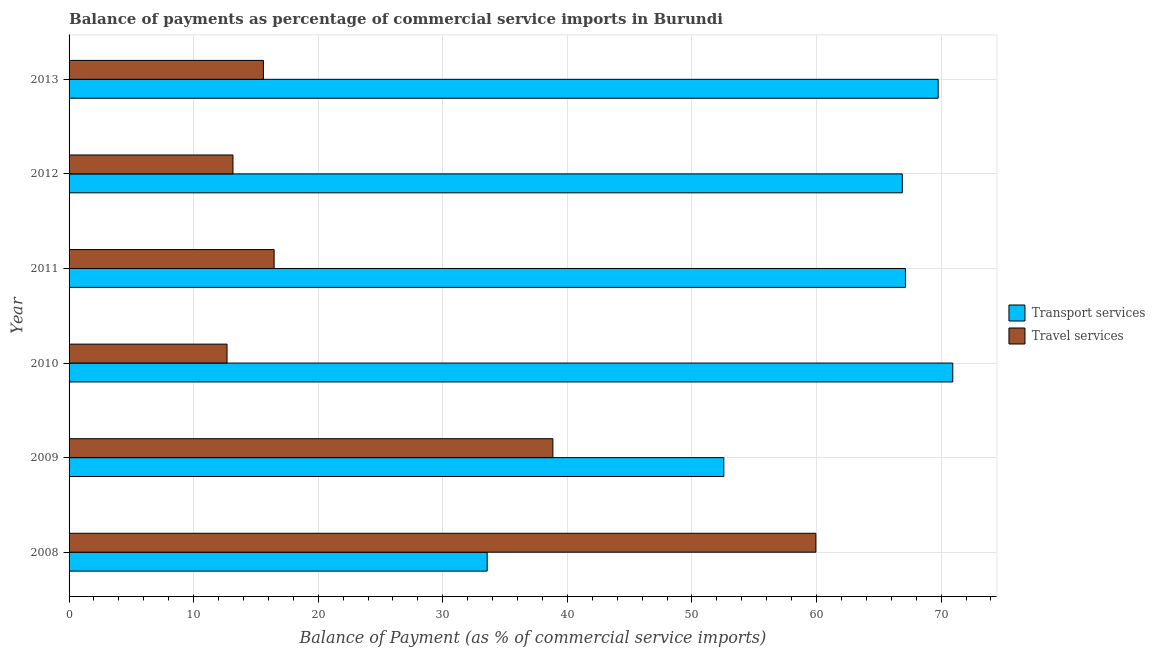How many groups of bars are there?
Give a very brief answer. 6. Are the number of bars on each tick of the Y-axis equal?
Keep it short and to the point. Yes. How many bars are there on the 3rd tick from the top?
Ensure brevity in your answer.  2. What is the label of the 4th group of bars from the top?
Your answer should be very brief. 2010. In how many cases, is the number of bars for a given year not equal to the number of legend labels?
Offer a very short reply. 0. What is the balance of payments of travel services in 2010?
Your answer should be compact. 12.68. Across all years, what is the maximum balance of payments of transport services?
Your response must be concise. 70.93. Across all years, what is the minimum balance of payments of travel services?
Your response must be concise. 12.68. In which year was the balance of payments of travel services maximum?
Ensure brevity in your answer.  2008. In which year was the balance of payments of travel services minimum?
Make the answer very short. 2010. What is the total balance of payments of travel services in the graph?
Ensure brevity in your answer.  156.67. What is the difference between the balance of payments of transport services in 2008 and that in 2011?
Ensure brevity in your answer.  -33.57. What is the difference between the balance of payments of travel services in 2011 and the balance of payments of transport services in 2010?
Provide a succinct answer. -54.47. What is the average balance of payments of transport services per year?
Your answer should be compact. 60.14. In the year 2012, what is the difference between the balance of payments of transport services and balance of payments of travel services?
Keep it short and to the point. 53.72. What is the ratio of the balance of payments of transport services in 2010 to that in 2011?
Your answer should be compact. 1.06. What is the difference between the highest and the second highest balance of payments of transport services?
Offer a terse response. 1.17. What is the difference between the highest and the lowest balance of payments of travel services?
Offer a terse response. 47.27. Is the sum of the balance of payments of travel services in 2009 and 2011 greater than the maximum balance of payments of transport services across all years?
Ensure brevity in your answer.  No. What does the 1st bar from the top in 2013 represents?
Provide a short and direct response. Travel services. What does the 2nd bar from the bottom in 2008 represents?
Give a very brief answer. Travel services. Are the values on the major ticks of X-axis written in scientific E-notation?
Your answer should be compact. No. Where does the legend appear in the graph?
Your response must be concise. Center right. How are the legend labels stacked?
Provide a succinct answer. Vertical. What is the title of the graph?
Offer a terse response. Balance of payments as percentage of commercial service imports in Burundi. What is the label or title of the X-axis?
Provide a succinct answer. Balance of Payment (as % of commercial service imports). What is the label or title of the Y-axis?
Provide a succinct answer. Year. What is the Balance of Payment (as % of commercial service imports) of Transport services in 2008?
Your response must be concise. 33.56. What is the Balance of Payment (as % of commercial service imports) of Travel services in 2008?
Provide a short and direct response. 59.94. What is the Balance of Payment (as % of commercial service imports) of Transport services in 2009?
Your answer should be compact. 52.56. What is the Balance of Payment (as % of commercial service imports) in Travel services in 2009?
Your response must be concise. 38.83. What is the Balance of Payment (as % of commercial service imports) in Transport services in 2010?
Your answer should be compact. 70.93. What is the Balance of Payment (as % of commercial service imports) of Travel services in 2010?
Your answer should be compact. 12.68. What is the Balance of Payment (as % of commercial service imports) of Transport services in 2011?
Provide a succinct answer. 67.13. What is the Balance of Payment (as % of commercial service imports) in Travel services in 2011?
Your response must be concise. 16.46. What is the Balance of Payment (as % of commercial service imports) of Transport services in 2012?
Provide a short and direct response. 66.88. What is the Balance of Payment (as % of commercial service imports) of Travel services in 2012?
Make the answer very short. 13.16. What is the Balance of Payment (as % of commercial service imports) in Transport services in 2013?
Provide a short and direct response. 69.76. What is the Balance of Payment (as % of commercial service imports) in Travel services in 2013?
Ensure brevity in your answer.  15.6. Across all years, what is the maximum Balance of Payment (as % of commercial service imports) of Transport services?
Make the answer very short. 70.93. Across all years, what is the maximum Balance of Payment (as % of commercial service imports) of Travel services?
Offer a terse response. 59.94. Across all years, what is the minimum Balance of Payment (as % of commercial service imports) of Transport services?
Ensure brevity in your answer.  33.56. Across all years, what is the minimum Balance of Payment (as % of commercial service imports) in Travel services?
Ensure brevity in your answer.  12.68. What is the total Balance of Payment (as % of commercial service imports) in Transport services in the graph?
Your answer should be compact. 360.82. What is the total Balance of Payment (as % of commercial service imports) in Travel services in the graph?
Your response must be concise. 156.67. What is the difference between the Balance of Payment (as % of commercial service imports) in Transport services in 2008 and that in 2009?
Make the answer very short. -18.99. What is the difference between the Balance of Payment (as % of commercial service imports) in Travel services in 2008 and that in 2009?
Your answer should be very brief. 21.11. What is the difference between the Balance of Payment (as % of commercial service imports) in Transport services in 2008 and that in 2010?
Offer a very short reply. -37.37. What is the difference between the Balance of Payment (as % of commercial service imports) of Travel services in 2008 and that in 2010?
Make the answer very short. 47.27. What is the difference between the Balance of Payment (as % of commercial service imports) of Transport services in 2008 and that in 2011?
Offer a very short reply. -33.57. What is the difference between the Balance of Payment (as % of commercial service imports) of Travel services in 2008 and that in 2011?
Make the answer very short. 43.49. What is the difference between the Balance of Payment (as % of commercial service imports) of Transport services in 2008 and that in 2012?
Give a very brief answer. -33.32. What is the difference between the Balance of Payment (as % of commercial service imports) of Travel services in 2008 and that in 2012?
Your answer should be very brief. 46.79. What is the difference between the Balance of Payment (as % of commercial service imports) in Transport services in 2008 and that in 2013?
Provide a short and direct response. -36.2. What is the difference between the Balance of Payment (as % of commercial service imports) of Travel services in 2008 and that in 2013?
Your answer should be compact. 44.34. What is the difference between the Balance of Payment (as % of commercial service imports) in Transport services in 2009 and that in 2010?
Keep it short and to the point. -18.38. What is the difference between the Balance of Payment (as % of commercial service imports) in Travel services in 2009 and that in 2010?
Your response must be concise. 26.16. What is the difference between the Balance of Payment (as % of commercial service imports) of Transport services in 2009 and that in 2011?
Ensure brevity in your answer.  -14.58. What is the difference between the Balance of Payment (as % of commercial service imports) in Travel services in 2009 and that in 2011?
Offer a very short reply. 22.37. What is the difference between the Balance of Payment (as % of commercial service imports) in Transport services in 2009 and that in 2012?
Make the answer very short. -14.32. What is the difference between the Balance of Payment (as % of commercial service imports) of Travel services in 2009 and that in 2012?
Keep it short and to the point. 25.68. What is the difference between the Balance of Payment (as % of commercial service imports) in Transport services in 2009 and that in 2013?
Keep it short and to the point. -17.21. What is the difference between the Balance of Payment (as % of commercial service imports) of Travel services in 2009 and that in 2013?
Offer a very short reply. 23.23. What is the difference between the Balance of Payment (as % of commercial service imports) in Transport services in 2010 and that in 2011?
Ensure brevity in your answer.  3.8. What is the difference between the Balance of Payment (as % of commercial service imports) in Travel services in 2010 and that in 2011?
Your answer should be compact. -3.78. What is the difference between the Balance of Payment (as % of commercial service imports) of Transport services in 2010 and that in 2012?
Your answer should be compact. 4.05. What is the difference between the Balance of Payment (as % of commercial service imports) of Travel services in 2010 and that in 2012?
Keep it short and to the point. -0.48. What is the difference between the Balance of Payment (as % of commercial service imports) of Transport services in 2010 and that in 2013?
Ensure brevity in your answer.  1.17. What is the difference between the Balance of Payment (as % of commercial service imports) of Travel services in 2010 and that in 2013?
Give a very brief answer. -2.92. What is the difference between the Balance of Payment (as % of commercial service imports) in Transport services in 2011 and that in 2012?
Offer a very short reply. 0.25. What is the difference between the Balance of Payment (as % of commercial service imports) in Travel services in 2011 and that in 2012?
Your response must be concise. 3.3. What is the difference between the Balance of Payment (as % of commercial service imports) of Transport services in 2011 and that in 2013?
Keep it short and to the point. -2.63. What is the difference between the Balance of Payment (as % of commercial service imports) in Travel services in 2011 and that in 2013?
Your answer should be compact. 0.86. What is the difference between the Balance of Payment (as % of commercial service imports) in Transport services in 2012 and that in 2013?
Ensure brevity in your answer.  -2.88. What is the difference between the Balance of Payment (as % of commercial service imports) in Travel services in 2012 and that in 2013?
Provide a short and direct response. -2.45. What is the difference between the Balance of Payment (as % of commercial service imports) in Transport services in 2008 and the Balance of Payment (as % of commercial service imports) in Travel services in 2009?
Ensure brevity in your answer.  -5.27. What is the difference between the Balance of Payment (as % of commercial service imports) of Transport services in 2008 and the Balance of Payment (as % of commercial service imports) of Travel services in 2010?
Offer a very short reply. 20.88. What is the difference between the Balance of Payment (as % of commercial service imports) of Transport services in 2008 and the Balance of Payment (as % of commercial service imports) of Travel services in 2011?
Ensure brevity in your answer.  17.1. What is the difference between the Balance of Payment (as % of commercial service imports) in Transport services in 2008 and the Balance of Payment (as % of commercial service imports) in Travel services in 2012?
Ensure brevity in your answer.  20.41. What is the difference between the Balance of Payment (as % of commercial service imports) in Transport services in 2008 and the Balance of Payment (as % of commercial service imports) in Travel services in 2013?
Give a very brief answer. 17.96. What is the difference between the Balance of Payment (as % of commercial service imports) in Transport services in 2009 and the Balance of Payment (as % of commercial service imports) in Travel services in 2010?
Offer a terse response. 39.88. What is the difference between the Balance of Payment (as % of commercial service imports) in Transport services in 2009 and the Balance of Payment (as % of commercial service imports) in Travel services in 2011?
Your answer should be very brief. 36.1. What is the difference between the Balance of Payment (as % of commercial service imports) in Transport services in 2009 and the Balance of Payment (as % of commercial service imports) in Travel services in 2012?
Give a very brief answer. 39.4. What is the difference between the Balance of Payment (as % of commercial service imports) of Transport services in 2009 and the Balance of Payment (as % of commercial service imports) of Travel services in 2013?
Provide a succinct answer. 36.95. What is the difference between the Balance of Payment (as % of commercial service imports) in Transport services in 2010 and the Balance of Payment (as % of commercial service imports) in Travel services in 2011?
Provide a succinct answer. 54.47. What is the difference between the Balance of Payment (as % of commercial service imports) of Transport services in 2010 and the Balance of Payment (as % of commercial service imports) of Travel services in 2012?
Keep it short and to the point. 57.78. What is the difference between the Balance of Payment (as % of commercial service imports) of Transport services in 2010 and the Balance of Payment (as % of commercial service imports) of Travel services in 2013?
Give a very brief answer. 55.33. What is the difference between the Balance of Payment (as % of commercial service imports) of Transport services in 2011 and the Balance of Payment (as % of commercial service imports) of Travel services in 2012?
Your response must be concise. 53.98. What is the difference between the Balance of Payment (as % of commercial service imports) of Transport services in 2011 and the Balance of Payment (as % of commercial service imports) of Travel services in 2013?
Offer a terse response. 51.53. What is the difference between the Balance of Payment (as % of commercial service imports) of Transport services in 2012 and the Balance of Payment (as % of commercial service imports) of Travel services in 2013?
Give a very brief answer. 51.28. What is the average Balance of Payment (as % of commercial service imports) of Transport services per year?
Ensure brevity in your answer.  60.14. What is the average Balance of Payment (as % of commercial service imports) in Travel services per year?
Ensure brevity in your answer.  26.11. In the year 2008, what is the difference between the Balance of Payment (as % of commercial service imports) in Transport services and Balance of Payment (as % of commercial service imports) in Travel services?
Your response must be concise. -26.38. In the year 2009, what is the difference between the Balance of Payment (as % of commercial service imports) in Transport services and Balance of Payment (as % of commercial service imports) in Travel services?
Ensure brevity in your answer.  13.72. In the year 2010, what is the difference between the Balance of Payment (as % of commercial service imports) in Transport services and Balance of Payment (as % of commercial service imports) in Travel services?
Give a very brief answer. 58.25. In the year 2011, what is the difference between the Balance of Payment (as % of commercial service imports) of Transport services and Balance of Payment (as % of commercial service imports) of Travel services?
Give a very brief answer. 50.67. In the year 2012, what is the difference between the Balance of Payment (as % of commercial service imports) of Transport services and Balance of Payment (as % of commercial service imports) of Travel services?
Your answer should be very brief. 53.72. In the year 2013, what is the difference between the Balance of Payment (as % of commercial service imports) in Transport services and Balance of Payment (as % of commercial service imports) in Travel services?
Provide a succinct answer. 54.16. What is the ratio of the Balance of Payment (as % of commercial service imports) in Transport services in 2008 to that in 2009?
Keep it short and to the point. 0.64. What is the ratio of the Balance of Payment (as % of commercial service imports) of Travel services in 2008 to that in 2009?
Offer a very short reply. 1.54. What is the ratio of the Balance of Payment (as % of commercial service imports) in Transport services in 2008 to that in 2010?
Provide a succinct answer. 0.47. What is the ratio of the Balance of Payment (as % of commercial service imports) in Travel services in 2008 to that in 2010?
Give a very brief answer. 4.73. What is the ratio of the Balance of Payment (as % of commercial service imports) of Transport services in 2008 to that in 2011?
Keep it short and to the point. 0.5. What is the ratio of the Balance of Payment (as % of commercial service imports) in Travel services in 2008 to that in 2011?
Offer a very short reply. 3.64. What is the ratio of the Balance of Payment (as % of commercial service imports) in Transport services in 2008 to that in 2012?
Keep it short and to the point. 0.5. What is the ratio of the Balance of Payment (as % of commercial service imports) in Travel services in 2008 to that in 2012?
Ensure brevity in your answer.  4.56. What is the ratio of the Balance of Payment (as % of commercial service imports) in Transport services in 2008 to that in 2013?
Ensure brevity in your answer.  0.48. What is the ratio of the Balance of Payment (as % of commercial service imports) in Travel services in 2008 to that in 2013?
Provide a short and direct response. 3.84. What is the ratio of the Balance of Payment (as % of commercial service imports) of Transport services in 2009 to that in 2010?
Make the answer very short. 0.74. What is the ratio of the Balance of Payment (as % of commercial service imports) of Travel services in 2009 to that in 2010?
Your answer should be compact. 3.06. What is the ratio of the Balance of Payment (as % of commercial service imports) in Transport services in 2009 to that in 2011?
Your answer should be compact. 0.78. What is the ratio of the Balance of Payment (as % of commercial service imports) in Travel services in 2009 to that in 2011?
Your answer should be very brief. 2.36. What is the ratio of the Balance of Payment (as % of commercial service imports) in Transport services in 2009 to that in 2012?
Offer a terse response. 0.79. What is the ratio of the Balance of Payment (as % of commercial service imports) in Travel services in 2009 to that in 2012?
Ensure brevity in your answer.  2.95. What is the ratio of the Balance of Payment (as % of commercial service imports) in Transport services in 2009 to that in 2013?
Your answer should be very brief. 0.75. What is the ratio of the Balance of Payment (as % of commercial service imports) of Travel services in 2009 to that in 2013?
Make the answer very short. 2.49. What is the ratio of the Balance of Payment (as % of commercial service imports) in Transport services in 2010 to that in 2011?
Your response must be concise. 1.06. What is the ratio of the Balance of Payment (as % of commercial service imports) in Travel services in 2010 to that in 2011?
Ensure brevity in your answer.  0.77. What is the ratio of the Balance of Payment (as % of commercial service imports) in Transport services in 2010 to that in 2012?
Make the answer very short. 1.06. What is the ratio of the Balance of Payment (as % of commercial service imports) in Travel services in 2010 to that in 2012?
Your answer should be compact. 0.96. What is the ratio of the Balance of Payment (as % of commercial service imports) in Transport services in 2010 to that in 2013?
Your answer should be compact. 1.02. What is the ratio of the Balance of Payment (as % of commercial service imports) in Travel services in 2010 to that in 2013?
Make the answer very short. 0.81. What is the ratio of the Balance of Payment (as % of commercial service imports) of Transport services in 2011 to that in 2012?
Your response must be concise. 1. What is the ratio of the Balance of Payment (as % of commercial service imports) in Travel services in 2011 to that in 2012?
Ensure brevity in your answer.  1.25. What is the ratio of the Balance of Payment (as % of commercial service imports) of Transport services in 2011 to that in 2013?
Ensure brevity in your answer.  0.96. What is the ratio of the Balance of Payment (as % of commercial service imports) in Travel services in 2011 to that in 2013?
Make the answer very short. 1.05. What is the ratio of the Balance of Payment (as % of commercial service imports) of Transport services in 2012 to that in 2013?
Keep it short and to the point. 0.96. What is the ratio of the Balance of Payment (as % of commercial service imports) of Travel services in 2012 to that in 2013?
Give a very brief answer. 0.84. What is the difference between the highest and the second highest Balance of Payment (as % of commercial service imports) of Transport services?
Provide a short and direct response. 1.17. What is the difference between the highest and the second highest Balance of Payment (as % of commercial service imports) of Travel services?
Offer a terse response. 21.11. What is the difference between the highest and the lowest Balance of Payment (as % of commercial service imports) in Transport services?
Provide a succinct answer. 37.37. What is the difference between the highest and the lowest Balance of Payment (as % of commercial service imports) in Travel services?
Provide a succinct answer. 47.27. 